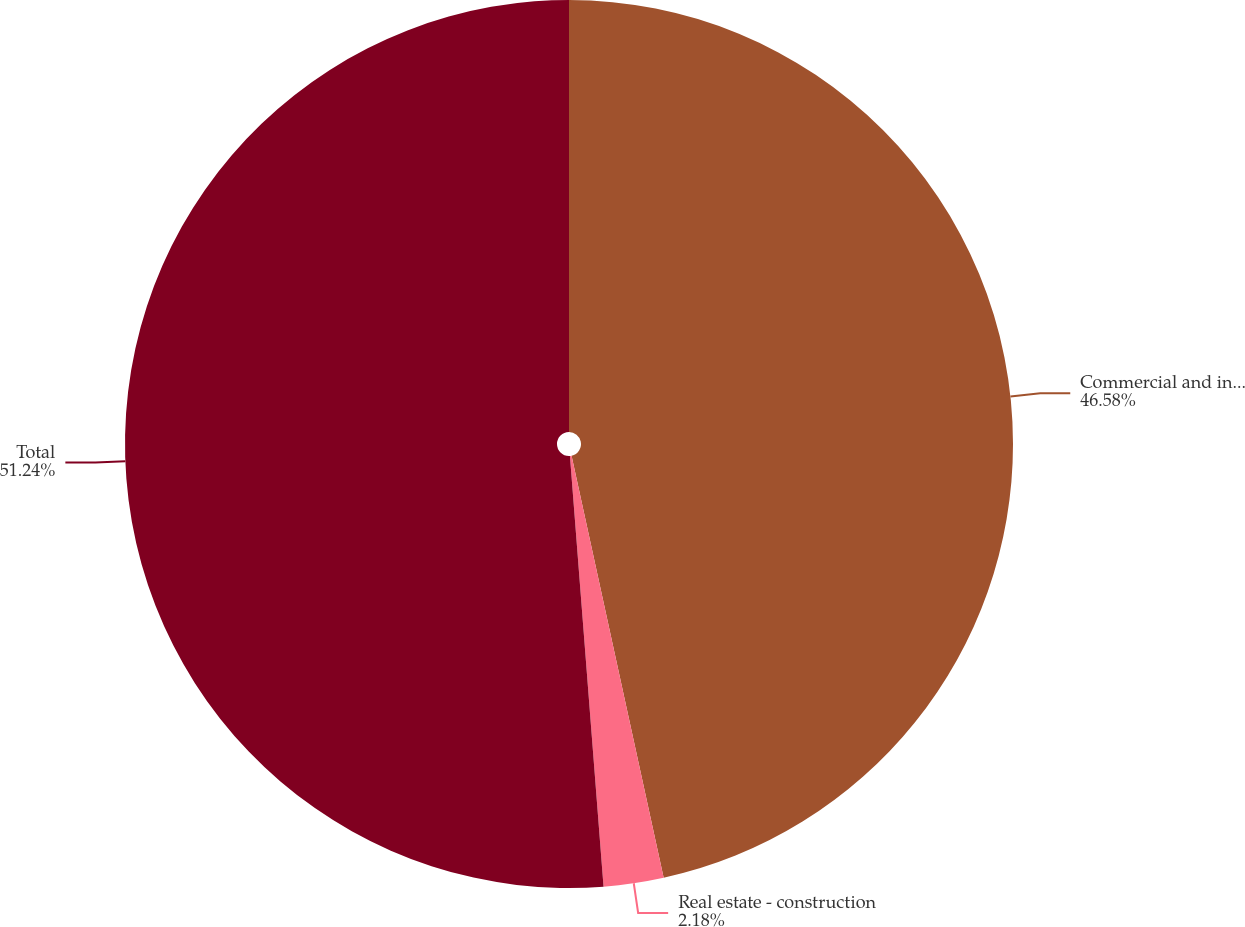Convert chart. <chart><loc_0><loc_0><loc_500><loc_500><pie_chart><fcel>Commercial and industrial<fcel>Real estate - construction<fcel>Total<nl><fcel>46.58%<fcel>2.18%<fcel>51.24%<nl></chart> 